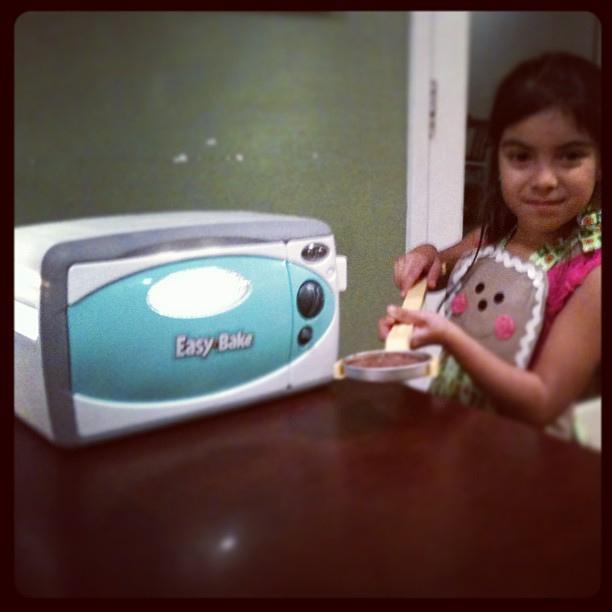Is "The oven is alongside the cake." an appropriate description for the image?
Answer yes or no. Yes. Does the caption "The oven is next to the cake." correctly depict the image?
Answer yes or no. Yes. Is "The oven is close to the cake." an appropriate description for the image?
Answer yes or no. Yes. Does the description: "The oven is across from the dining table." accurately reflect the image?
Answer yes or no. No. 